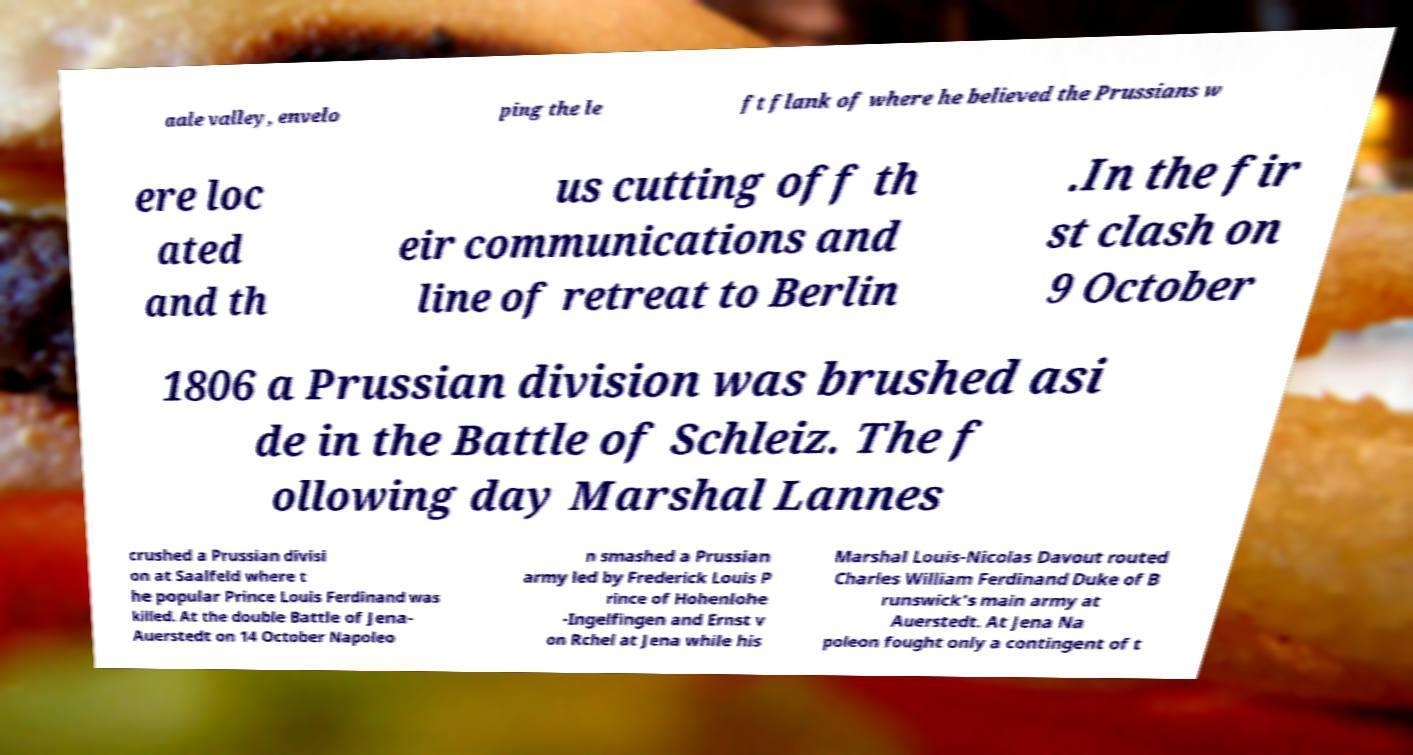Can you accurately transcribe the text from the provided image for me? aale valley, envelo ping the le ft flank of where he believed the Prussians w ere loc ated and th us cutting off th eir communications and line of retreat to Berlin .In the fir st clash on 9 October 1806 a Prussian division was brushed asi de in the Battle of Schleiz. The f ollowing day Marshal Lannes crushed a Prussian divisi on at Saalfeld where t he popular Prince Louis Ferdinand was killed. At the double Battle of Jena- Auerstedt on 14 October Napoleo n smashed a Prussian army led by Frederick Louis P rince of Hohenlohe -Ingelfingen and Ernst v on Rchel at Jena while his Marshal Louis-Nicolas Davout routed Charles William Ferdinand Duke of B runswick's main army at Auerstedt. At Jena Na poleon fought only a contingent of t 